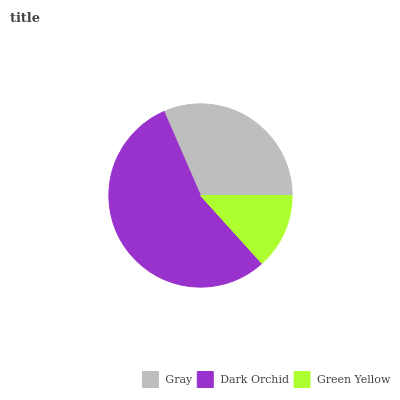Is Green Yellow the minimum?
Answer yes or no. Yes. Is Dark Orchid the maximum?
Answer yes or no. Yes. Is Dark Orchid the minimum?
Answer yes or no. No. Is Green Yellow the maximum?
Answer yes or no. No. Is Dark Orchid greater than Green Yellow?
Answer yes or no. Yes. Is Green Yellow less than Dark Orchid?
Answer yes or no. Yes. Is Green Yellow greater than Dark Orchid?
Answer yes or no. No. Is Dark Orchid less than Green Yellow?
Answer yes or no. No. Is Gray the high median?
Answer yes or no. Yes. Is Gray the low median?
Answer yes or no. Yes. Is Green Yellow the high median?
Answer yes or no. No. Is Dark Orchid the low median?
Answer yes or no. No. 